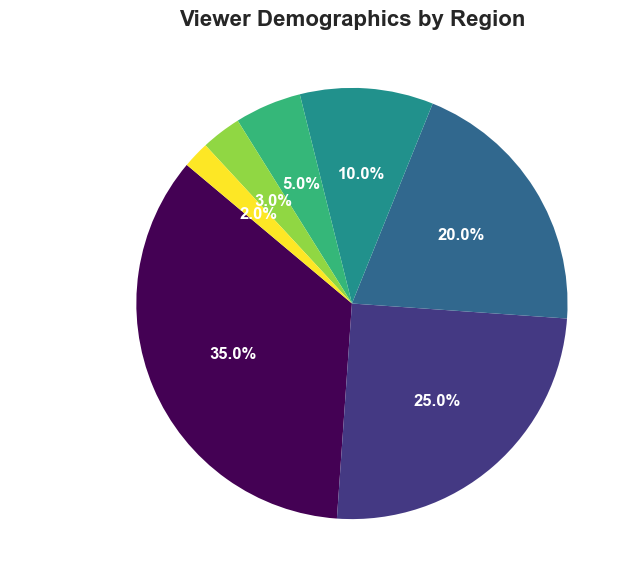What percentage of viewers are from Europe? The pie chart labels show Europe has a percentage of 25%.
Answer: 25% Which region has the highest proportion of viewers? By observing the pie chart, the segment for North America is the largest, indicating the highest proportion of viewers.
Answer: North America How many percentage points higher is North America's viewership compared to Asia's? North America's percentage is 35%, and Asia's percentage is 20%. Subtracting Asia's percentage from North America's gives 35% - 20% = 15%.
Answer: 15% What is the combined percentage of viewers from South America and Africa? The percentage of viewers from South America is 10%, and from Africa is 5%. Adding these together results in 10% + 5% = 15%.
Answer: 15% Which regions have less than 5% of the viewership? The pie chart shows that Australia has 3% and "Other" has 2%, both of which are less than 5%.
Answer: Australia, Other How does the viewership of South America and Australia compare? The pie chart shows South America with 10% and Australia with 3%. Therefore, South America has a higher viewership than Australia.
Answer: South America has higher viewership What's the average percentage of viewers across North America, Europe, and Asia? The percentages are 35% for North America, 25% for Europe, and 20% for Asia. Adding these gives 35% + 25% + 20% = 80%. Dividing by 3 yields an average of 80% / 3 ≈ 26.7%.
Answer: 26.7% How much larger is the viewership of North America compared to Africa? North America has 35%, and Africa has 5%. Subtracting Africa's percentage from North America's gives 35% - 5% = 30%.
Answer: 30% Which region has the smallest viewer percentage, and what is that percentage? The pie chart shows "Other" with the smallest percentage of viewers, which is 2%.
Answer: Other, 2% What is the total percentage of viewers from Asia, Africa, and Australia combined? Asia has 20%, Africa has 5%, and Australia has 3%. Adding these gives 20% + 5% + 3% = 28%.
Answer: 28% 